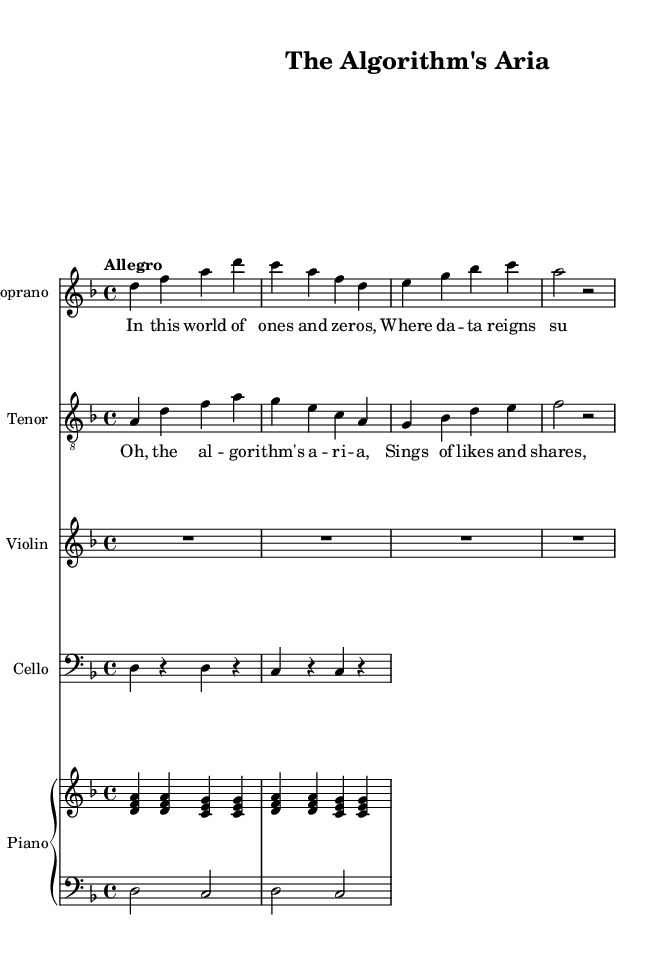What is the key signature of this music? The key signature is D minor, which has one flat. This can be determined by looking at the key signature indicated at the beginning of the score.
Answer: D minor What is the time signature of this piece? The time signature is 4/4, which is indicated at the beginning of the score. This means there are four beats per measure, and each quarter note gets one beat.
Answer: 4/4 What is the tempo marking for this piece? The tempo marking is "Allegro", which suggests a fast, lively tempo. This is found at the beginning of the score, right after the time signature.
Answer: Allegro How many measures are in the Soprano part? The Soprano part contains 4 measures, which can be counted from the musical notation provided. Each grouping between the vertical lines represents one measure.
Answer: 4 Which instruments are included in this score? The instruments included are Soprano, Tenor, Violin, Cello, and Piano. This information is found at the beginning of each staff, where the instrument names are listed.
Answer: Soprano, Tenor, Violin, Cello, Piano What text is sung in the first verse? The text sung in the first verse is "In this world of ones and ze -- ros, Where da -- ta reigns su -- preme," which is indicated under the Soprano staff.
Answer: In this world of ones and zeros, Where data reigns supreme What is the format of the musical score? The musical score is in a multi-staff format, indicated by separate staves for each instrument, with corresponding lyrics underneath the vocal parts. This layout supports both vocal and instrumental performances.
Answer: Multi-staff 